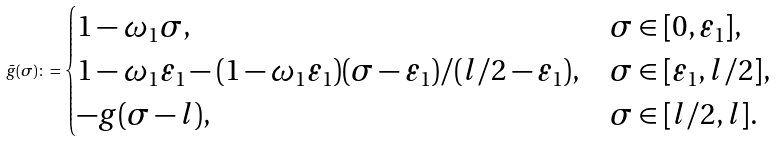<formula> <loc_0><loc_0><loc_500><loc_500>\bar { g } ( \sigma ) \colon = \begin{cases} 1 - \omega _ { 1 } \sigma , & \sigma \in [ 0 , \varepsilon _ { 1 } ] , \\ 1 - \omega _ { 1 } \varepsilon _ { 1 } - ( 1 - \omega _ { 1 } \varepsilon _ { 1 } ) ( \sigma - \varepsilon _ { 1 } ) / ( l / 2 - \varepsilon _ { 1 } ) , & \sigma \in [ \varepsilon _ { 1 } , l / 2 ] , \\ - g ( \sigma - l ) , & \sigma \in [ l / 2 , l ] . \end{cases}</formula> 